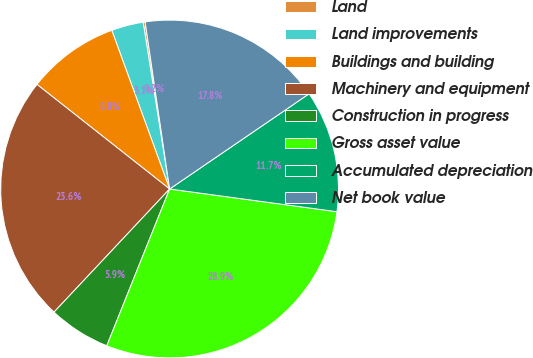Convert chart. <chart><loc_0><loc_0><loc_500><loc_500><pie_chart><fcel>Land<fcel>Land improvements<fcel>Buildings and building<fcel>Machinery and equipment<fcel>Construction in progress<fcel>Gross asset value<fcel>Accumulated depreciation<fcel>Net book value<nl><fcel>0.19%<fcel>3.06%<fcel>8.81%<fcel>23.63%<fcel>5.93%<fcel>28.92%<fcel>11.68%<fcel>17.78%<nl></chart> 